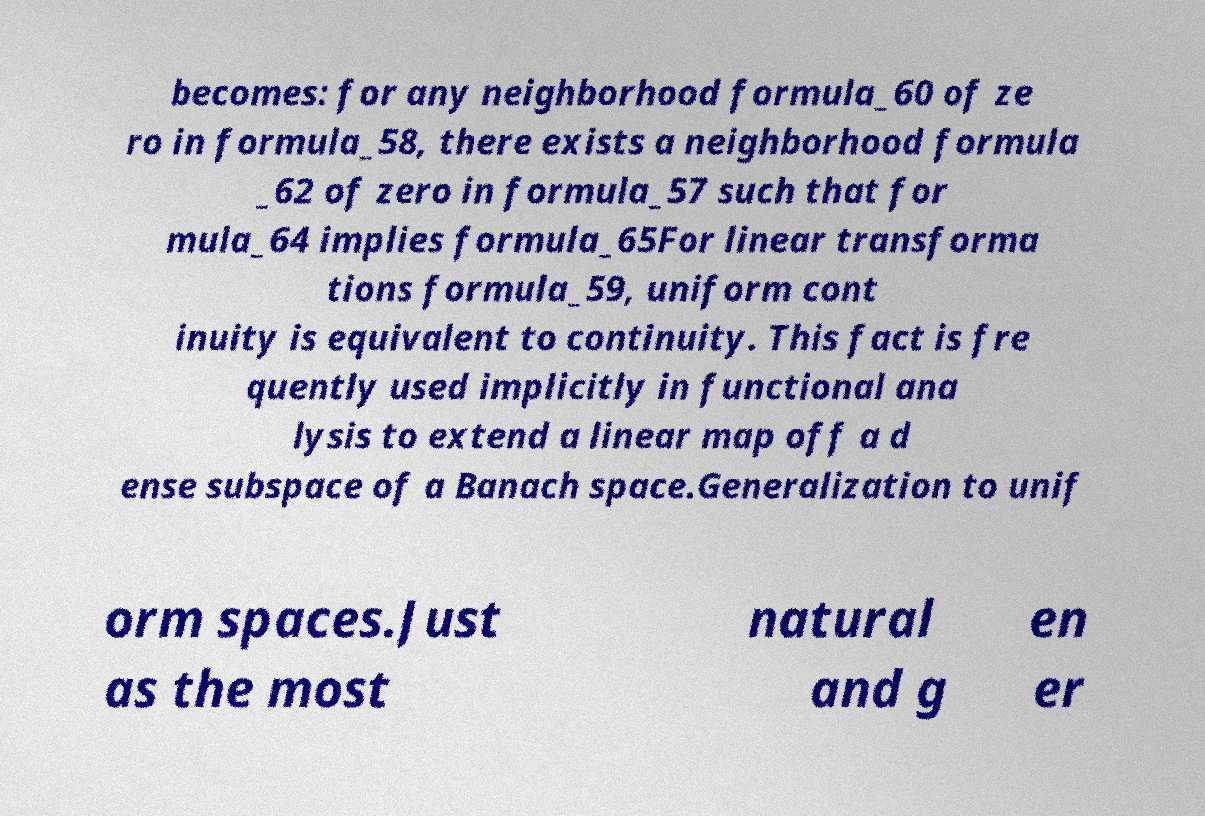Could you assist in decoding the text presented in this image and type it out clearly? becomes: for any neighborhood formula_60 of ze ro in formula_58, there exists a neighborhood formula _62 of zero in formula_57 such that for mula_64 implies formula_65For linear transforma tions formula_59, uniform cont inuity is equivalent to continuity. This fact is fre quently used implicitly in functional ana lysis to extend a linear map off a d ense subspace of a Banach space.Generalization to unif orm spaces.Just as the most natural and g en er 